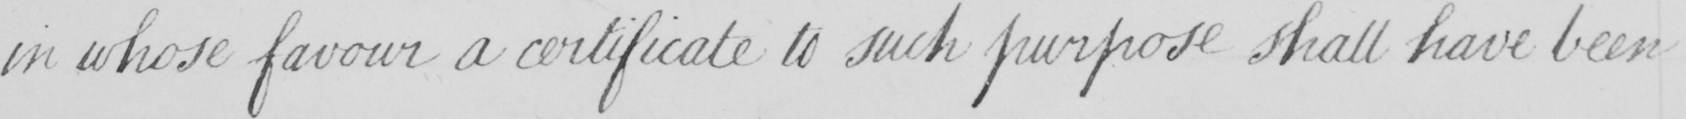What text is written in this handwritten line? in whose favour a certificate to such purpose shall have been 